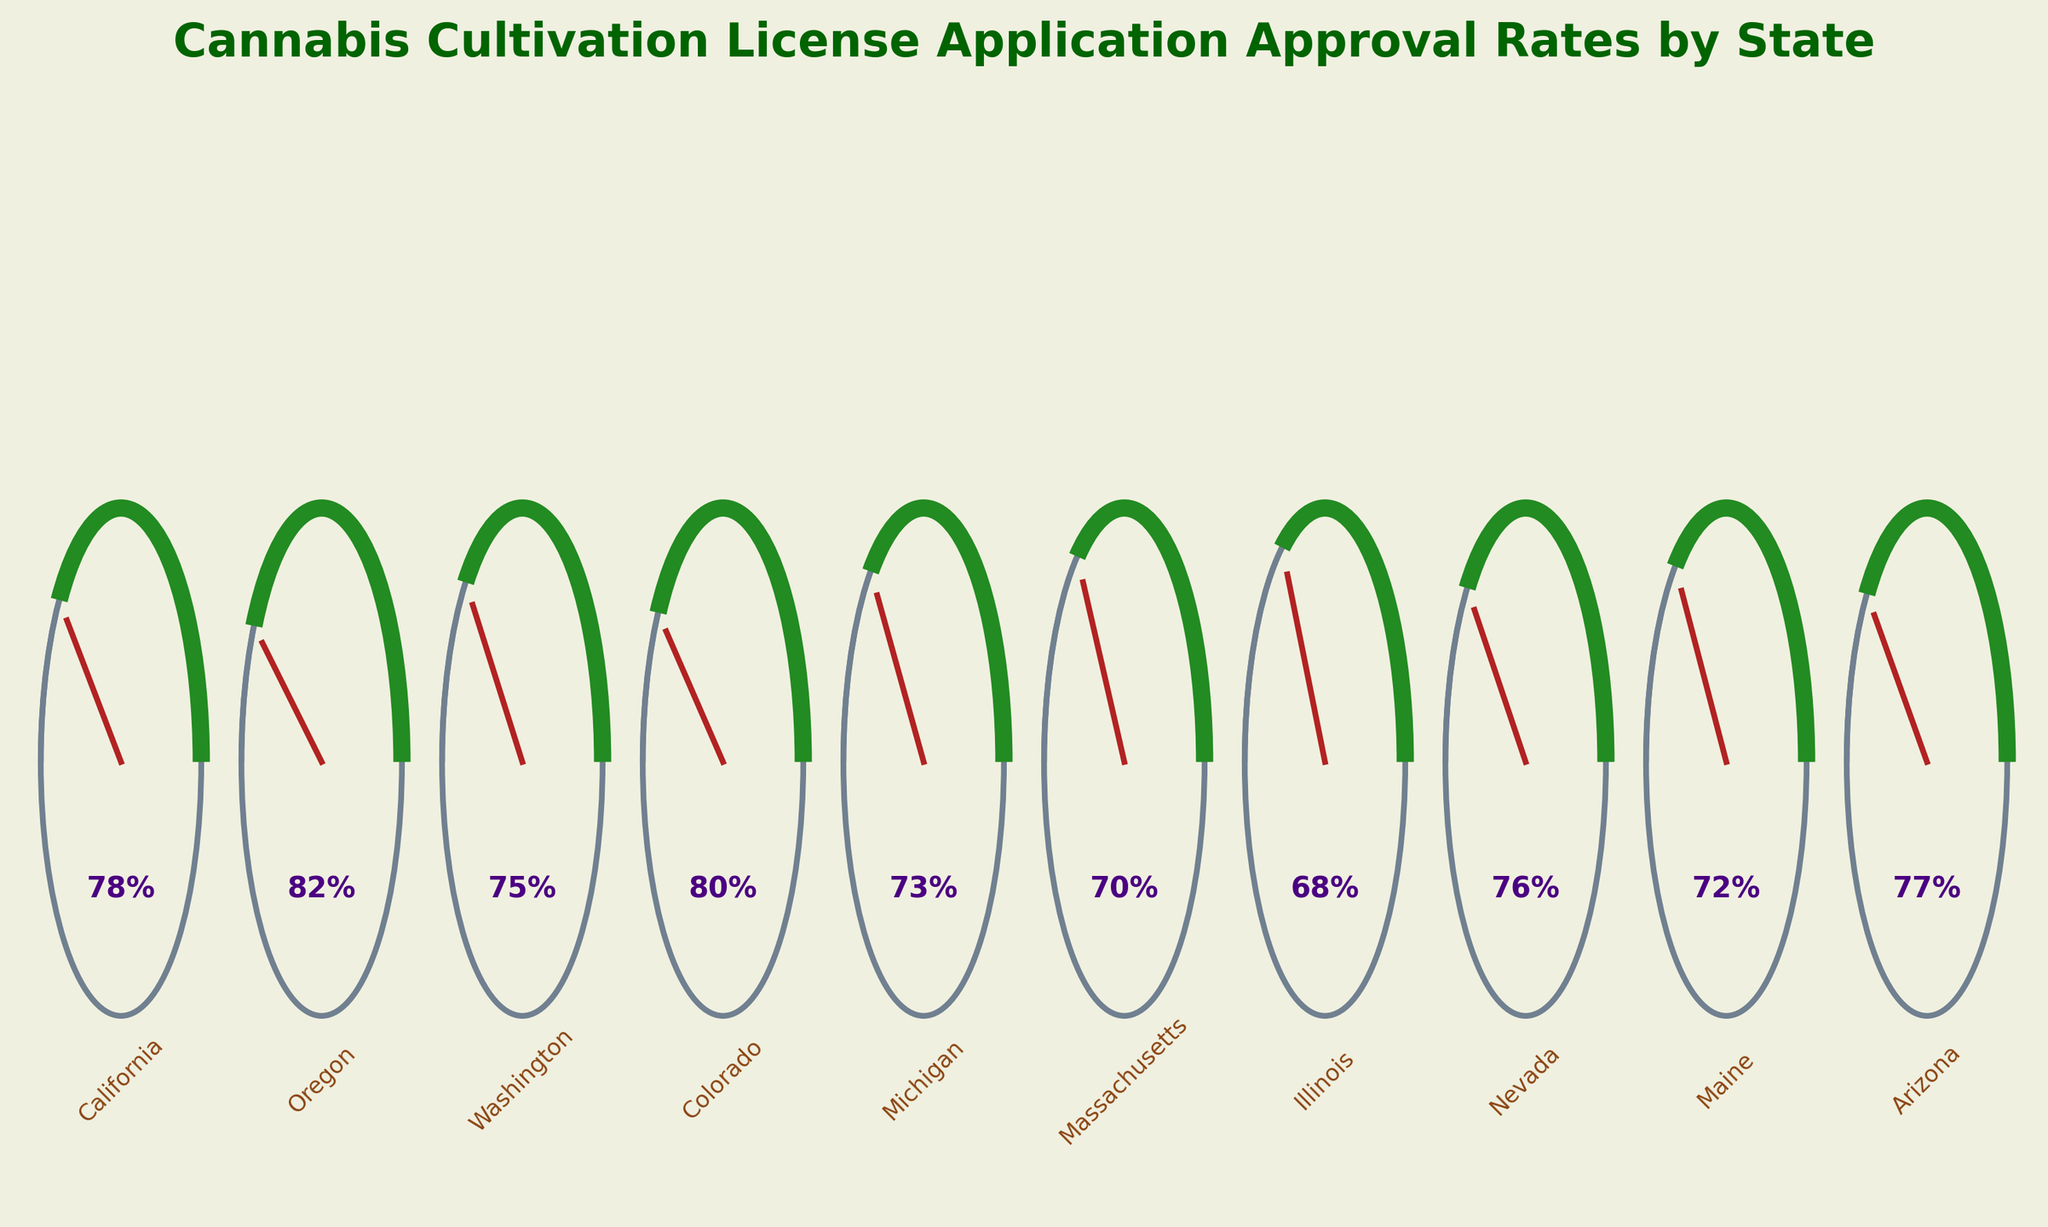What's the title of the figure? The title is displayed at the top center of the figure, giving an overview of what the figure is about.
Answer: Cannabis Cultivation License Application Approval Rates by State How many states are represented in the figure? Count the number of states labeled on the x-axis of the figure to determine the total number of states included.
Answer: 10 Which state has the highest approval rate? Locate the gauge with the highest angle and corresponding percentage value.
Answer: Oregon Which state has the lowest approval rate? Locate the gauge with the lowest angle and corresponding percentage value.
Answer: Illinois What is the average approval rate across all states? Add up all the approval rates and divide by the number of states: (78 + 82 + 75 + 80 + 73 + 70 + 68 + 76 + 72 + 77) / 10 = 751 / 10.
Answer: 75.1% Are there any states with an approval rate below 70%? Look for states with their approval rates displayed below 70%.
Answer: No Which states have an approval rate higher than 75%? Identify states with approval rates displayed to be higher than 75%.
Answer: California, Oregon, Colorado, Arizona Is the approval rate in Michigan greater than that in Maine? Compare the percentage approval rates of Michigan and Maine displayed below each gauge.
Answer: No What is the difference between the highest and lowest approval rates? Subtract the lowest approval rate from the highest approval rate: 82% (Oregon) - 68% (Illinois).
Answer: 14% How does Nevada's approval rate compare with Washington's? Compare the percentage approval rates of Nevada and Washington as displayed on the figure.
Answer: Nevada's rate is 1% higher 